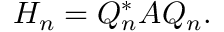Convert formula to latex. <formula><loc_0><loc_0><loc_500><loc_500>H _ { n } = Q _ { n } ^ { * } A Q _ { n } .</formula> 